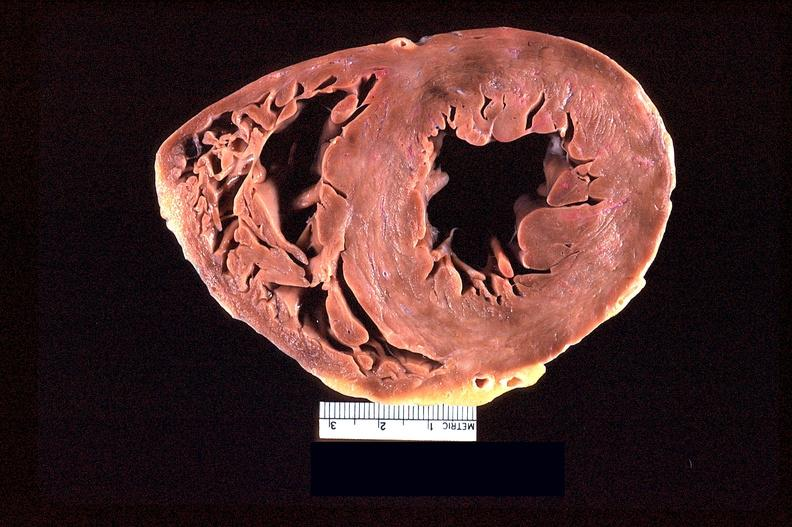what does this image show?
Answer the question using a single word or phrase. Heart slice 